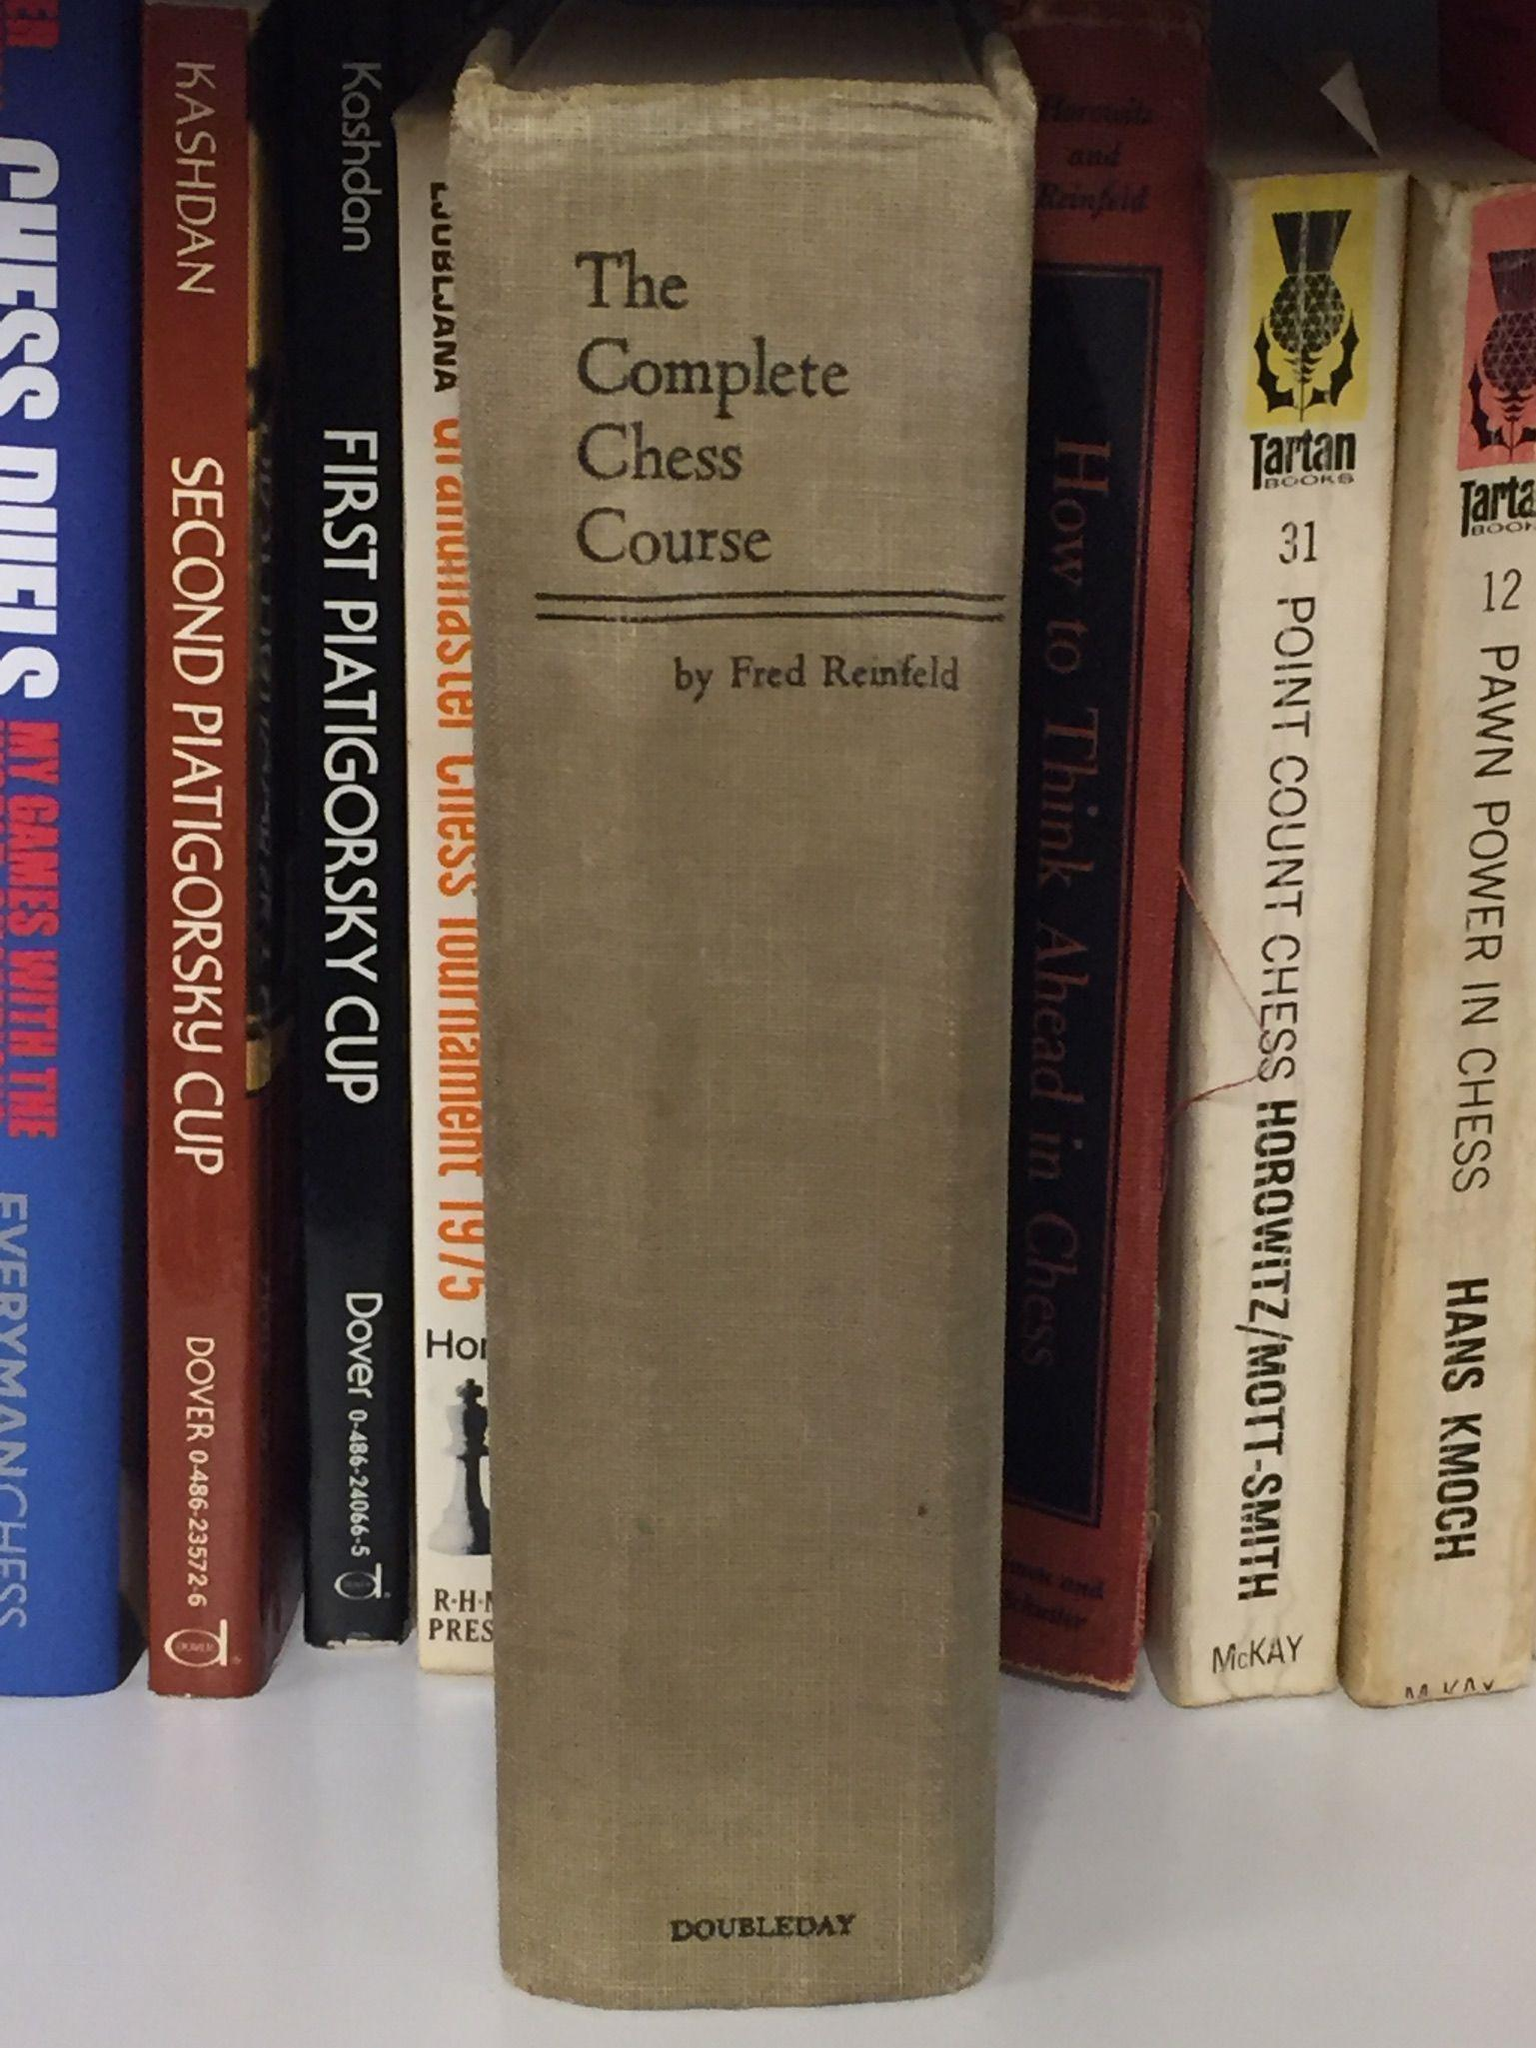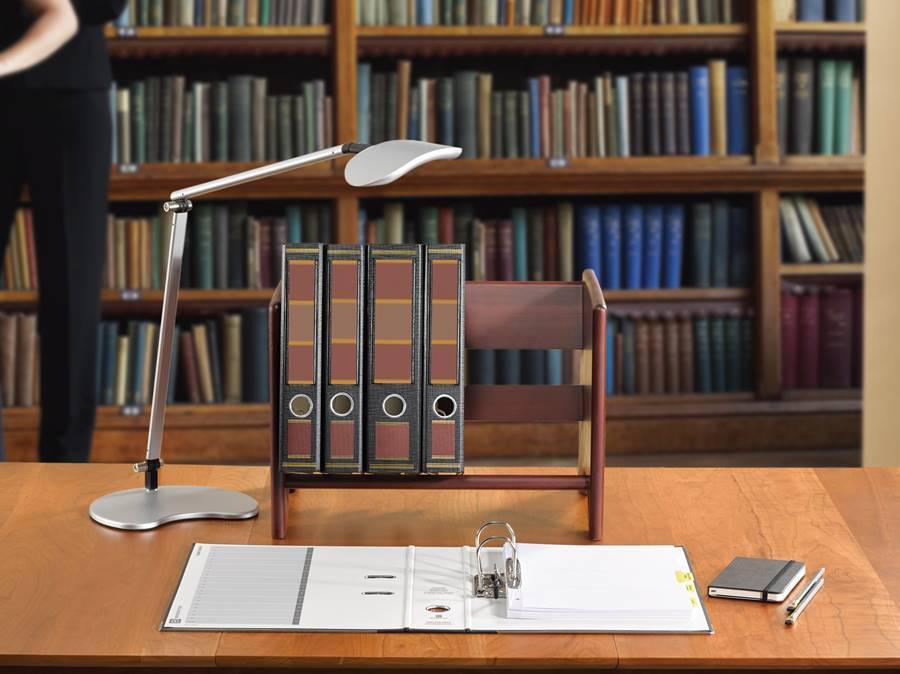The first image is the image on the left, the second image is the image on the right. Given the left and right images, does the statement "At least one image shows a single row of colored binders with white rectangular labels." hold true? Answer yes or no. No. The first image is the image on the left, the second image is the image on the right. Evaluate the accuracy of this statement regarding the images: "There are shelves in the image on the right". Is it true? Answer yes or no. Yes. 